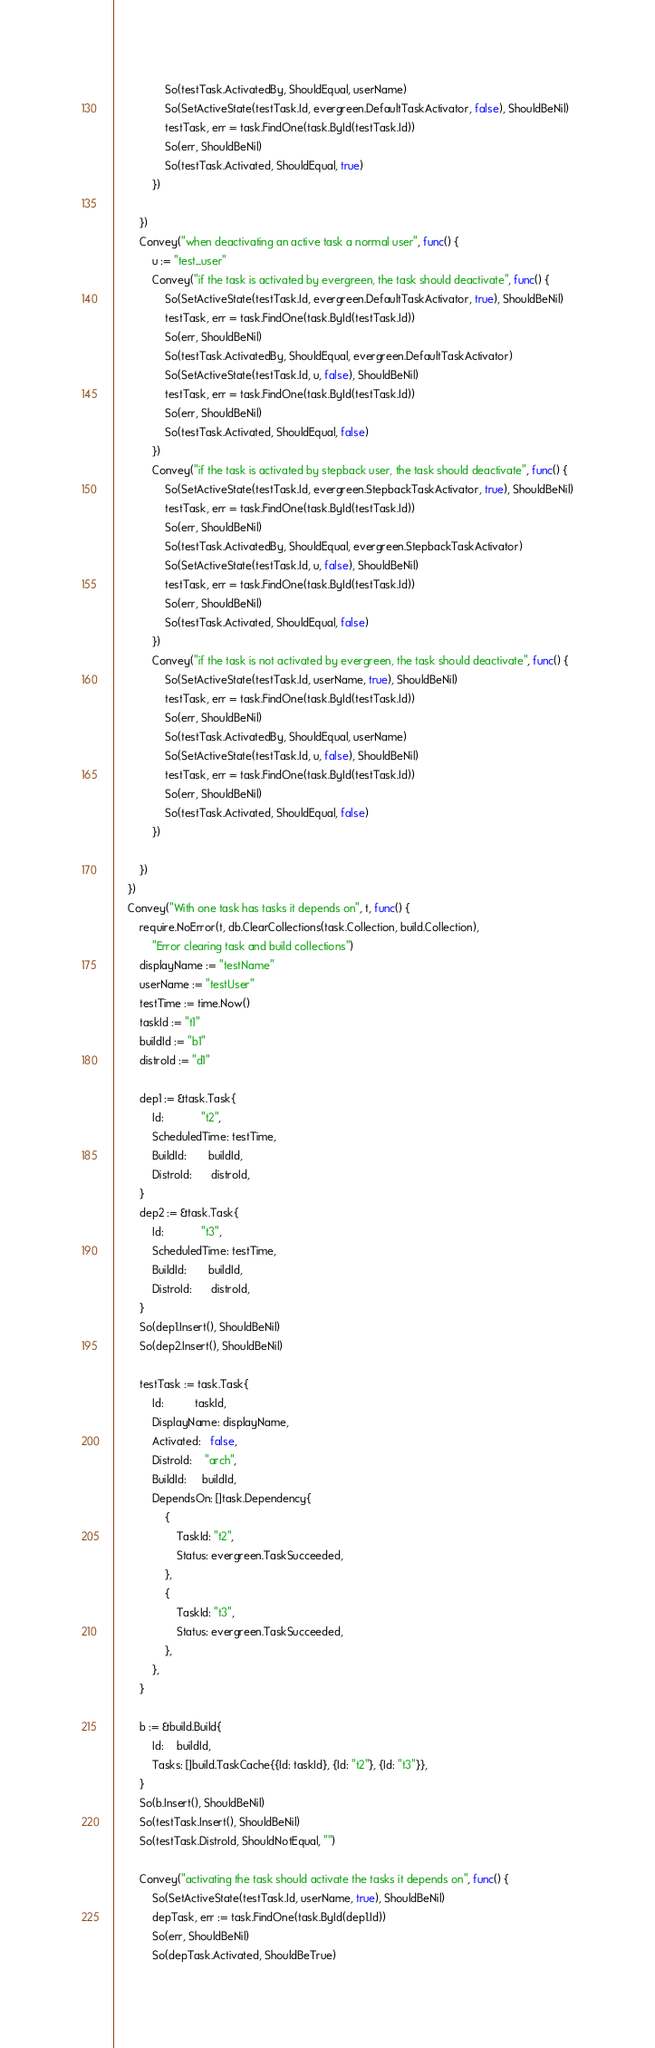<code> <loc_0><loc_0><loc_500><loc_500><_Go_>				So(testTask.ActivatedBy, ShouldEqual, userName)
				So(SetActiveState(testTask.Id, evergreen.DefaultTaskActivator, false), ShouldBeNil)
				testTask, err = task.FindOne(task.ById(testTask.Id))
				So(err, ShouldBeNil)
				So(testTask.Activated, ShouldEqual, true)
			})

		})
		Convey("when deactivating an active task a normal user", func() {
			u := "test_user"
			Convey("if the task is activated by evergreen, the task should deactivate", func() {
				So(SetActiveState(testTask.Id, evergreen.DefaultTaskActivator, true), ShouldBeNil)
				testTask, err = task.FindOne(task.ById(testTask.Id))
				So(err, ShouldBeNil)
				So(testTask.ActivatedBy, ShouldEqual, evergreen.DefaultTaskActivator)
				So(SetActiveState(testTask.Id, u, false), ShouldBeNil)
				testTask, err = task.FindOne(task.ById(testTask.Id))
				So(err, ShouldBeNil)
				So(testTask.Activated, ShouldEqual, false)
			})
			Convey("if the task is activated by stepback user, the task should deactivate", func() {
				So(SetActiveState(testTask.Id, evergreen.StepbackTaskActivator, true), ShouldBeNil)
				testTask, err = task.FindOne(task.ById(testTask.Id))
				So(err, ShouldBeNil)
				So(testTask.ActivatedBy, ShouldEqual, evergreen.StepbackTaskActivator)
				So(SetActiveState(testTask.Id, u, false), ShouldBeNil)
				testTask, err = task.FindOne(task.ById(testTask.Id))
				So(err, ShouldBeNil)
				So(testTask.Activated, ShouldEqual, false)
			})
			Convey("if the task is not activated by evergreen, the task should deactivate", func() {
				So(SetActiveState(testTask.Id, userName, true), ShouldBeNil)
				testTask, err = task.FindOne(task.ById(testTask.Id))
				So(err, ShouldBeNil)
				So(testTask.ActivatedBy, ShouldEqual, userName)
				So(SetActiveState(testTask.Id, u, false), ShouldBeNil)
				testTask, err = task.FindOne(task.ById(testTask.Id))
				So(err, ShouldBeNil)
				So(testTask.Activated, ShouldEqual, false)
			})

		})
	})
	Convey("With one task has tasks it depends on", t, func() {
		require.NoError(t, db.ClearCollections(task.Collection, build.Collection),
			"Error clearing task and build collections")
		displayName := "testName"
		userName := "testUser"
		testTime := time.Now()
		taskId := "t1"
		buildId := "b1"
		distroId := "d1"

		dep1 := &task.Task{
			Id:            "t2",
			ScheduledTime: testTime,
			BuildId:       buildId,
			DistroId:      distroId,
		}
		dep2 := &task.Task{
			Id:            "t3",
			ScheduledTime: testTime,
			BuildId:       buildId,
			DistroId:      distroId,
		}
		So(dep1.Insert(), ShouldBeNil)
		So(dep2.Insert(), ShouldBeNil)

		testTask := task.Task{
			Id:          taskId,
			DisplayName: displayName,
			Activated:   false,
			DistroId:    "arch",
			BuildId:     buildId,
			DependsOn: []task.Dependency{
				{
					TaskId: "t2",
					Status: evergreen.TaskSucceeded,
				},
				{
					TaskId: "t3",
					Status: evergreen.TaskSucceeded,
				},
			},
		}

		b := &build.Build{
			Id:    buildId,
			Tasks: []build.TaskCache{{Id: taskId}, {Id: "t2"}, {Id: "t3"}},
		}
		So(b.Insert(), ShouldBeNil)
		So(testTask.Insert(), ShouldBeNil)
		So(testTask.DistroId, ShouldNotEqual, "")

		Convey("activating the task should activate the tasks it depends on", func() {
			So(SetActiveState(testTask.Id, userName, true), ShouldBeNil)
			depTask, err := task.FindOne(task.ById(dep1.Id))
			So(err, ShouldBeNil)
			So(depTask.Activated, ShouldBeTrue)
</code> 